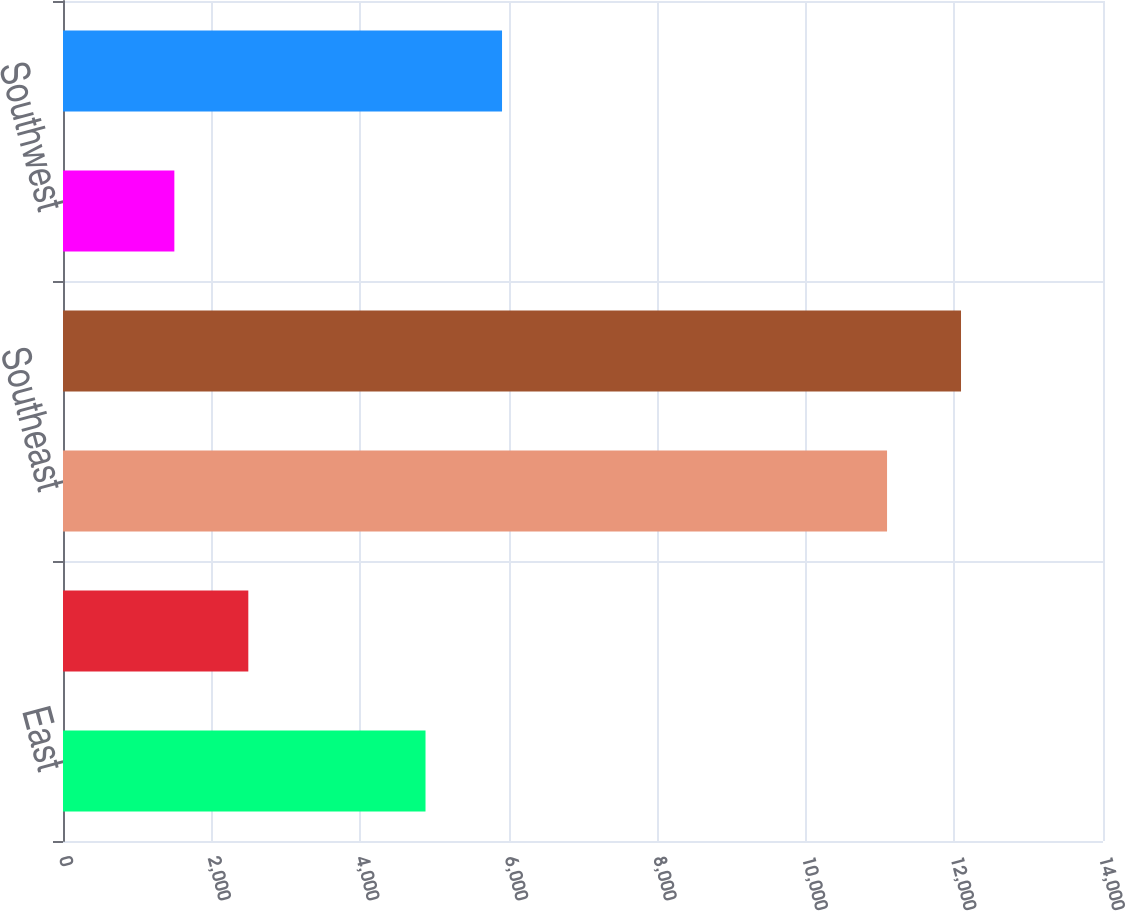<chart> <loc_0><loc_0><loc_500><loc_500><bar_chart><fcel>East<fcel>Midwest<fcel>Southeast<fcel>South Central<fcel>Southwest<fcel>West<nl><fcel>4880<fcel>2494.6<fcel>11093<fcel>12088.6<fcel>1499<fcel>5910<nl></chart> 